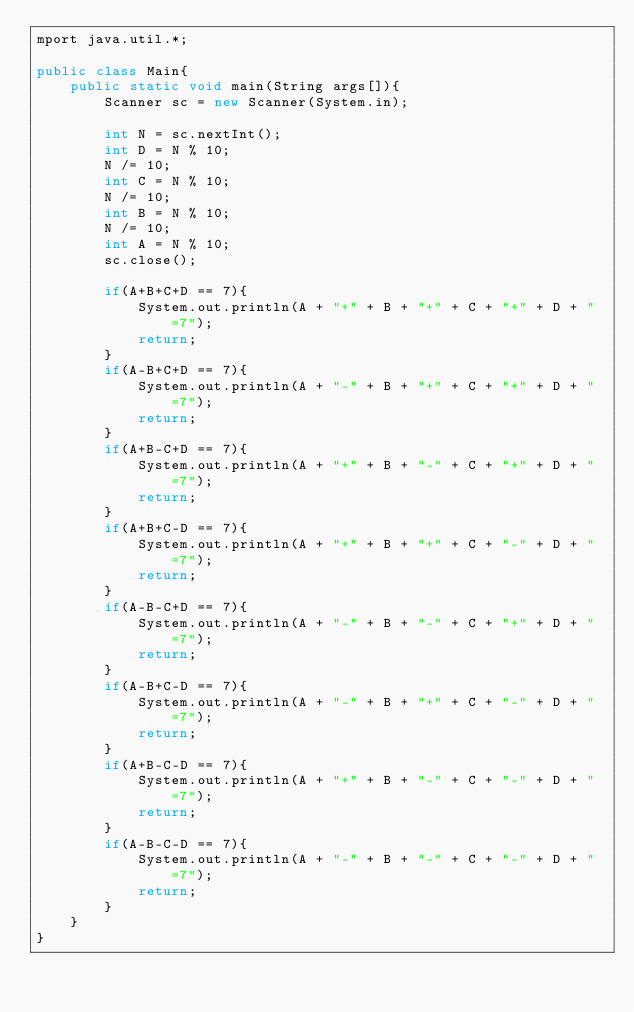Convert code to text. <code><loc_0><loc_0><loc_500><loc_500><_Java_>mport java.util.*;
 
public class Main{
    public static void main(String args[]){
        Scanner sc = new Scanner(System.in);

        int N = sc.nextInt();
        int D = N % 10;
        N /= 10;
        int C = N % 10;
        N /= 10;
        int B = N % 10;
        N /= 10;
        int A = N % 10;
        sc.close();

        if(A+B+C+D == 7){
            System.out.println(A + "+" + B + "+" + C + "+" + D + "=7");
            return;
        }
        if(A-B+C+D == 7){
            System.out.println(A + "-" + B + "+" + C + "+" + D + "=7");
            return;
        }
        if(A+B-C+D == 7){
            System.out.println(A + "+" + B + "-" + C + "+" + D + "=7");
            return;
        }
        if(A+B+C-D == 7){
            System.out.println(A + "+" + B + "+" + C + "-" + D + "=7");
            return;
        }
        if(A-B-C+D == 7){
            System.out.println(A + "-" + B + "-" + C + "+" + D + "=7");
            return;
        }
        if(A-B+C-D == 7){
            System.out.println(A + "-" + B + "+" + C + "-" + D + "=7");
            return;
        }
        if(A+B-C-D == 7){
            System.out.println(A + "+" + B + "-" + C + "-" + D + "=7");
            return;
        }
        if(A-B-C-D == 7){
            System.out.println(A + "-" + B + "-" + C + "-" + D + "=7");
            return;
        }
    }
}</code> 